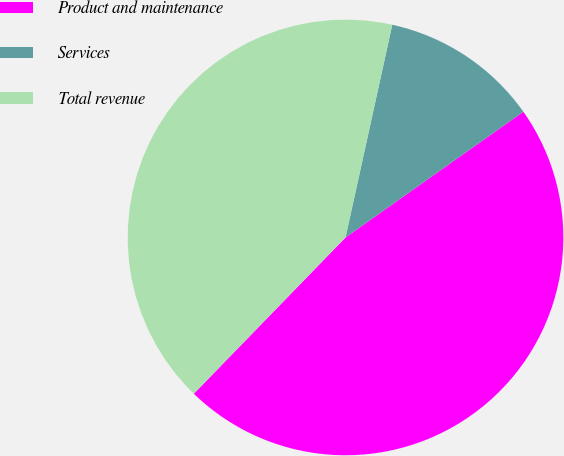Convert chart to OTSL. <chart><loc_0><loc_0><loc_500><loc_500><pie_chart><fcel>Product and maintenance<fcel>Services<fcel>Total revenue<nl><fcel>47.06%<fcel>11.76%<fcel>41.18%<nl></chart> 